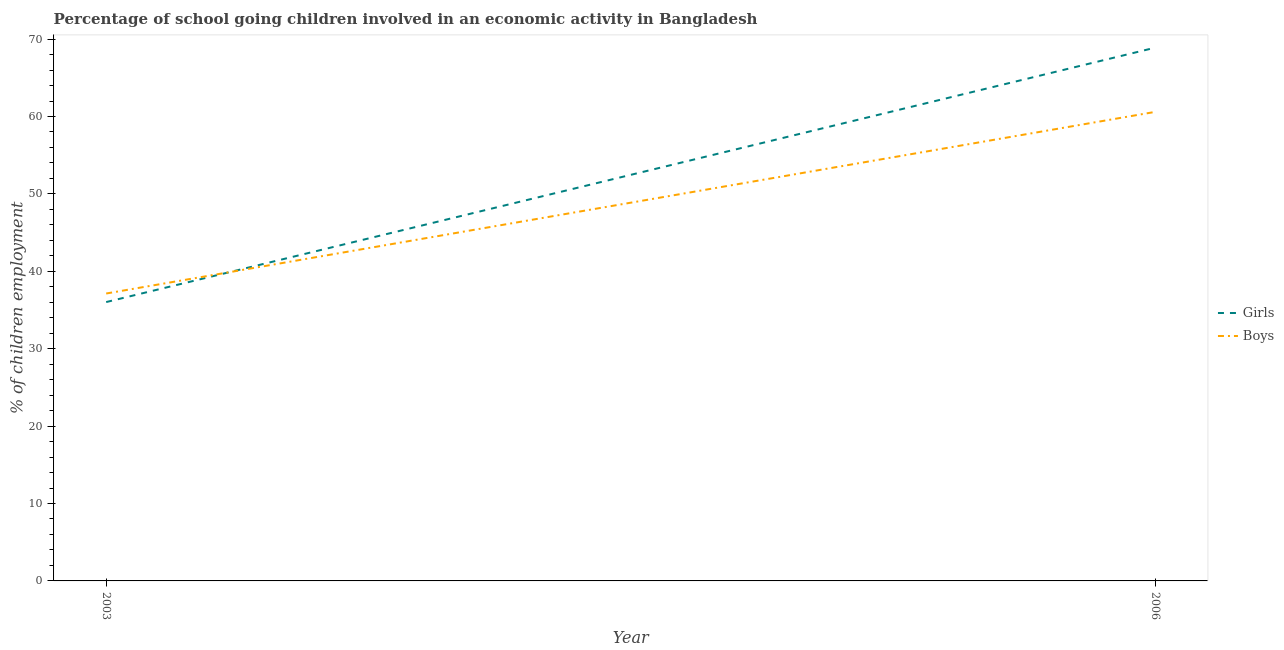Is the number of lines equal to the number of legend labels?
Provide a succinct answer. Yes. What is the percentage of school going boys in 2003?
Offer a terse response. 37.13. Across all years, what is the maximum percentage of school going boys?
Keep it short and to the point. 60.6. Across all years, what is the minimum percentage of school going boys?
Make the answer very short. 37.13. In which year was the percentage of school going girls maximum?
Your answer should be compact. 2006. What is the total percentage of school going girls in the graph?
Offer a terse response. 104.92. What is the difference between the percentage of school going boys in 2003 and that in 2006?
Your answer should be very brief. -23.47. What is the difference between the percentage of school going girls in 2006 and the percentage of school going boys in 2003?
Give a very brief answer. 31.77. What is the average percentage of school going boys per year?
Provide a short and direct response. 48.86. In the year 2006, what is the difference between the percentage of school going girls and percentage of school going boys?
Offer a very short reply. 8.3. What is the ratio of the percentage of school going girls in 2003 to that in 2006?
Provide a short and direct response. 0.52. In how many years, is the percentage of school going girls greater than the average percentage of school going girls taken over all years?
Your answer should be compact. 1. Does the percentage of school going girls monotonically increase over the years?
Provide a short and direct response. Yes. Is the percentage of school going boys strictly greater than the percentage of school going girls over the years?
Keep it short and to the point. No. Is the percentage of school going girls strictly less than the percentage of school going boys over the years?
Your answer should be compact. No. How many years are there in the graph?
Give a very brief answer. 2. How many legend labels are there?
Give a very brief answer. 2. What is the title of the graph?
Make the answer very short. Percentage of school going children involved in an economic activity in Bangladesh. Does "Diarrhea" appear as one of the legend labels in the graph?
Ensure brevity in your answer.  No. What is the label or title of the X-axis?
Provide a succinct answer. Year. What is the label or title of the Y-axis?
Your answer should be compact. % of children employment. What is the % of children employment of Girls in 2003?
Your answer should be compact. 36.02. What is the % of children employment in Boys in 2003?
Provide a succinct answer. 37.13. What is the % of children employment of Girls in 2006?
Provide a short and direct response. 68.9. What is the % of children employment in Boys in 2006?
Provide a succinct answer. 60.6. Across all years, what is the maximum % of children employment of Girls?
Offer a very short reply. 68.9. Across all years, what is the maximum % of children employment of Boys?
Ensure brevity in your answer.  60.6. Across all years, what is the minimum % of children employment in Girls?
Keep it short and to the point. 36.02. Across all years, what is the minimum % of children employment of Boys?
Ensure brevity in your answer.  37.13. What is the total % of children employment in Girls in the graph?
Offer a terse response. 104.92. What is the total % of children employment in Boys in the graph?
Your answer should be compact. 97.73. What is the difference between the % of children employment in Girls in 2003 and that in 2006?
Keep it short and to the point. -32.88. What is the difference between the % of children employment in Boys in 2003 and that in 2006?
Your answer should be compact. -23.47. What is the difference between the % of children employment of Girls in 2003 and the % of children employment of Boys in 2006?
Your answer should be compact. -24.58. What is the average % of children employment in Girls per year?
Your answer should be compact. 52.46. What is the average % of children employment in Boys per year?
Offer a very short reply. 48.86. In the year 2003, what is the difference between the % of children employment of Girls and % of children employment of Boys?
Give a very brief answer. -1.11. In the year 2006, what is the difference between the % of children employment of Girls and % of children employment of Boys?
Give a very brief answer. 8.3. What is the ratio of the % of children employment of Girls in 2003 to that in 2006?
Provide a succinct answer. 0.52. What is the ratio of the % of children employment in Boys in 2003 to that in 2006?
Provide a short and direct response. 0.61. What is the difference between the highest and the second highest % of children employment of Girls?
Offer a terse response. 32.88. What is the difference between the highest and the second highest % of children employment of Boys?
Your response must be concise. 23.47. What is the difference between the highest and the lowest % of children employment in Girls?
Keep it short and to the point. 32.88. What is the difference between the highest and the lowest % of children employment in Boys?
Your answer should be compact. 23.47. 